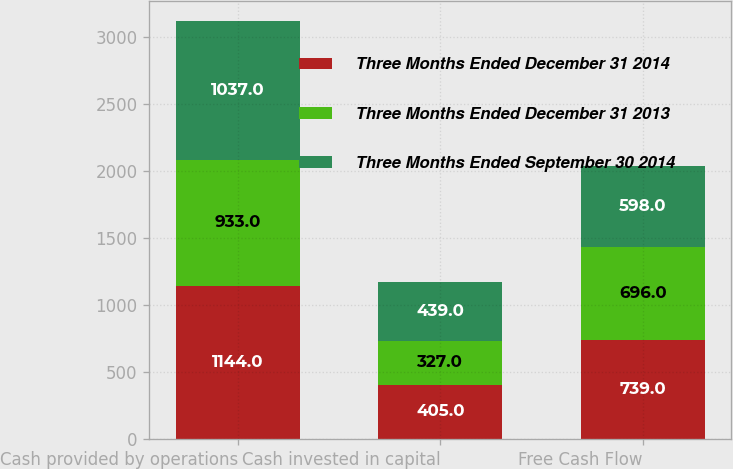<chart> <loc_0><loc_0><loc_500><loc_500><stacked_bar_chart><ecel><fcel>Cash provided by operations<fcel>Cash invested in capital<fcel>Free Cash Flow<nl><fcel>Three Months Ended December 31 2014<fcel>1144<fcel>405<fcel>739<nl><fcel>Three Months Ended December 31 2013<fcel>933<fcel>327<fcel>696<nl><fcel>Three Months Ended September 30 2014<fcel>1037<fcel>439<fcel>598<nl></chart> 